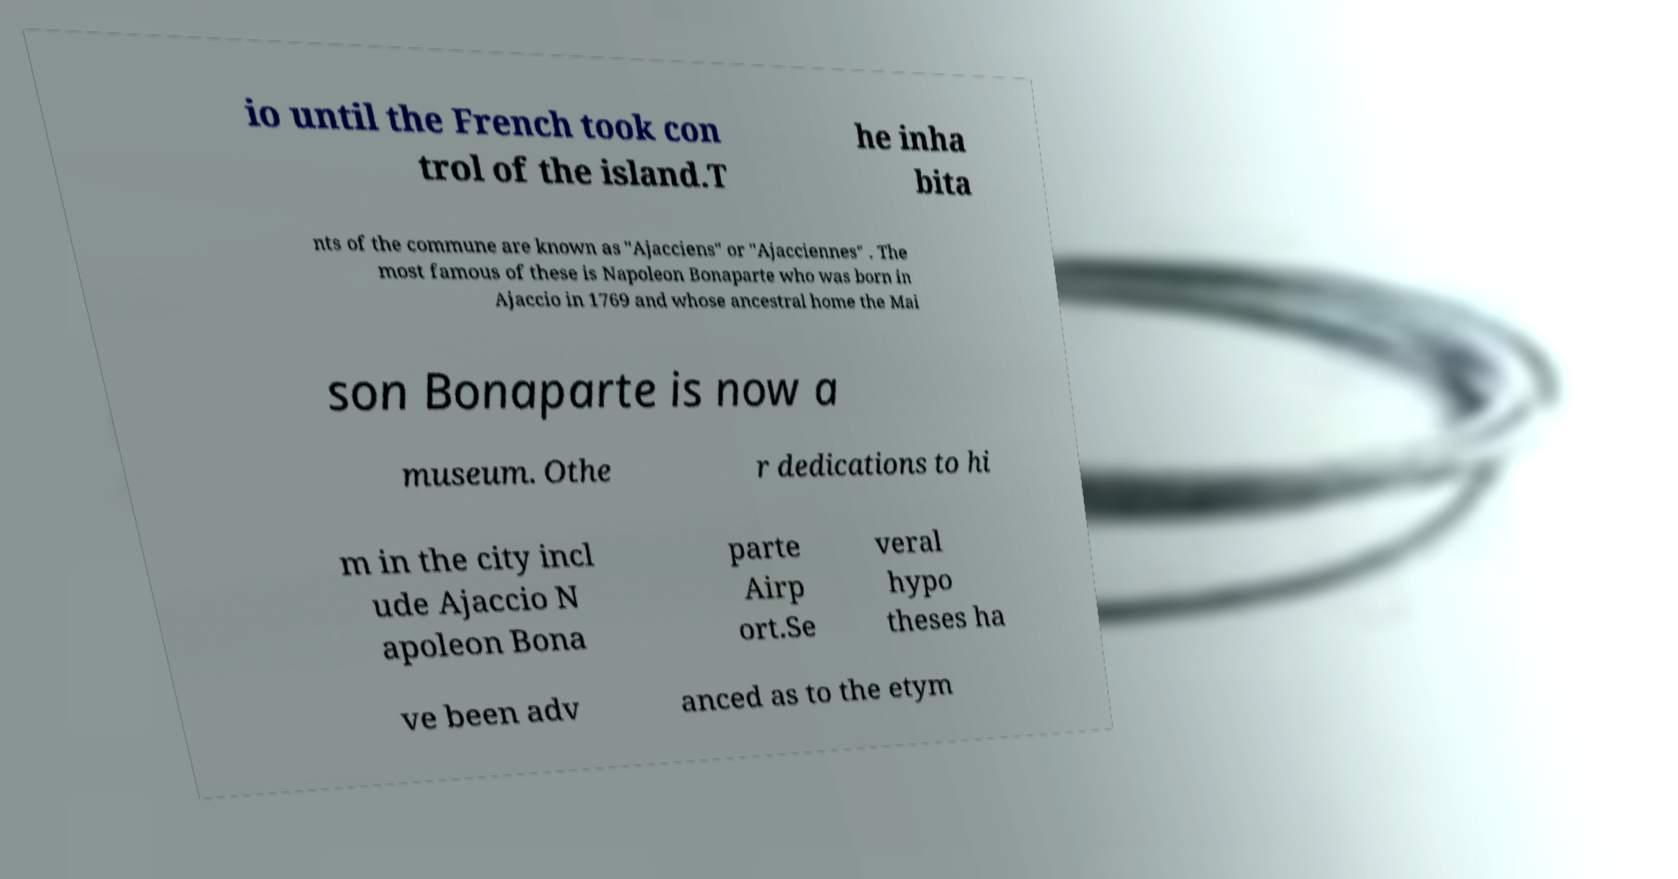Could you extract and type out the text from this image? io until the French took con trol of the island.T he inha bita nts of the commune are known as "Ajacciens" or "Ajacciennes" . The most famous of these is Napoleon Bonaparte who was born in Ajaccio in 1769 and whose ancestral home the Mai son Bonaparte is now a museum. Othe r dedications to hi m in the city incl ude Ajaccio N apoleon Bona parte Airp ort.Se veral hypo theses ha ve been adv anced as to the etym 